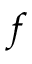Convert formula to latex. <formula><loc_0><loc_0><loc_500><loc_500>f</formula> 